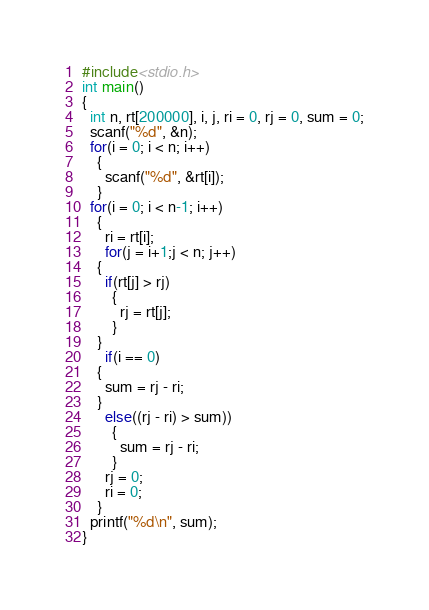Convert code to text. <code><loc_0><loc_0><loc_500><loc_500><_C_>#include<stdio.h>
int main()
{
  int n, rt[200000], i, j, ri = 0, rj = 0, sum = 0;
  scanf("%d", &n);
  for(i = 0; i < n; i++)
    {
      scanf("%d", &rt[i]);
    }
  for(i = 0; i < n-1; i++)
    {
      ri = rt[i];
      for(j = i+1;j < n; j++)
	{
	  if(rt[j] > rj)
	    {
	      rj = rt[j];
	    }
	}
      if(i == 0)
	{
	  sum = rj - ri;
	}
      else((rj - ri) > sum))
	    {
	      sum = rj - ri;
	    }
      rj = 0;
      ri = 0;
    }
  printf("%d\n", sum);
}

</code> 